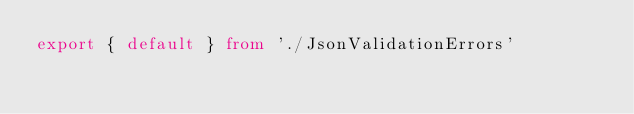<code> <loc_0><loc_0><loc_500><loc_500><_TypeScript_>export { default } from './JsonValidationErrors'
</code> 